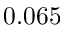<formula> <loc_0><loc_0><loc_500><loc_500>0 . 0 6 5</formula> 